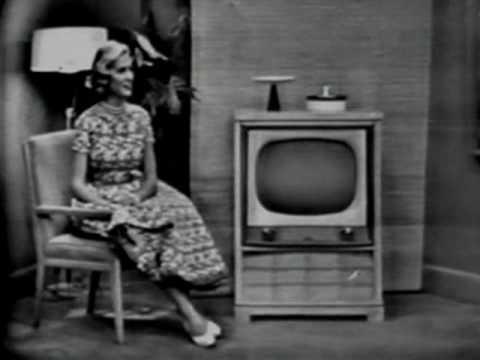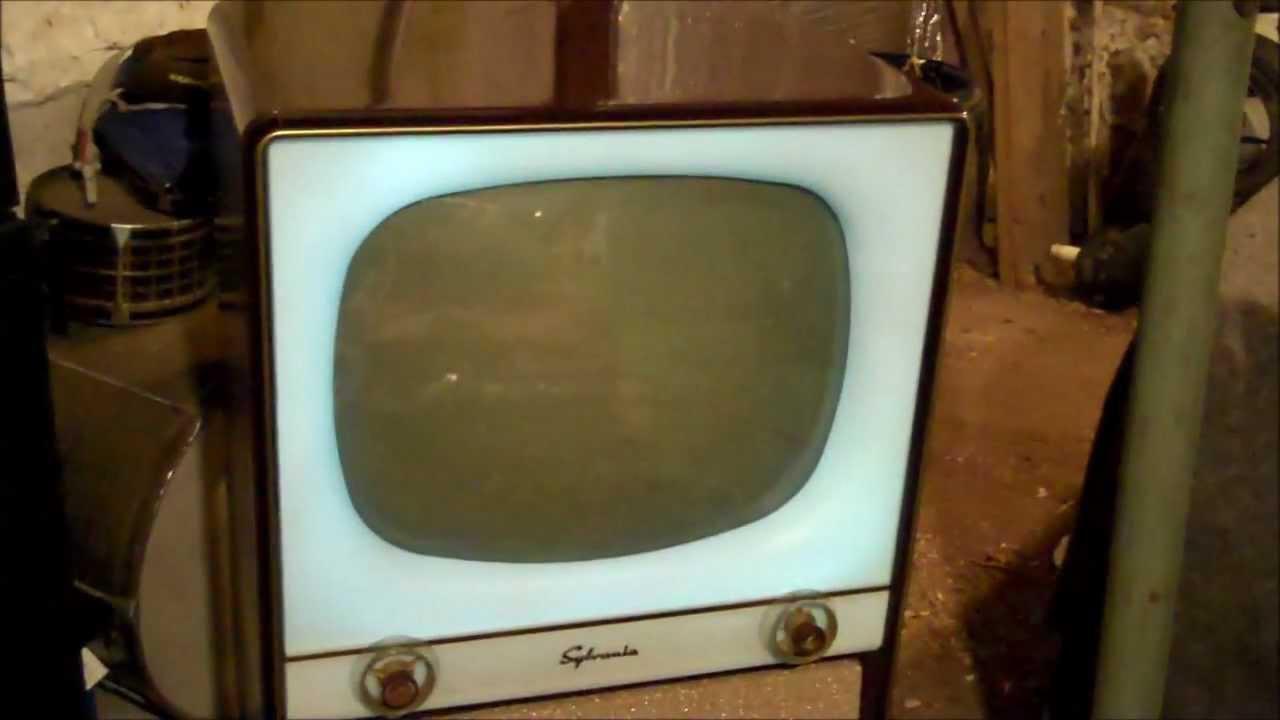The first image is the image on the left, the second image is the image on the right. Evaluate the accuracy of this statement regarding the images: "In one of the images, there is a single person by the TV.". Is it true? Answer yes or no. Yes. The first image is the image on the left, the second image is the image on the right. Considering the images on both sides, is "There is one person next to a television" valid? Answer yes or no. Yes. 